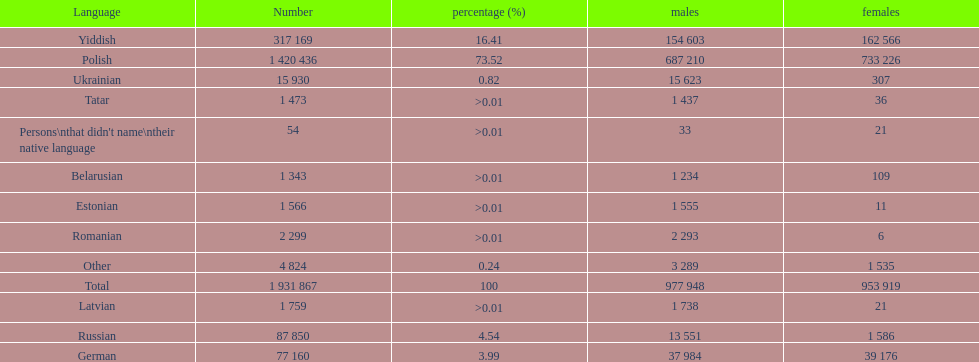Is german above or below russia in the number of people who speak that language? Below. 